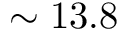<formula> <loc_0><loc_0><loc_500><loc_500>\sim 1 3 . 8</formula> 